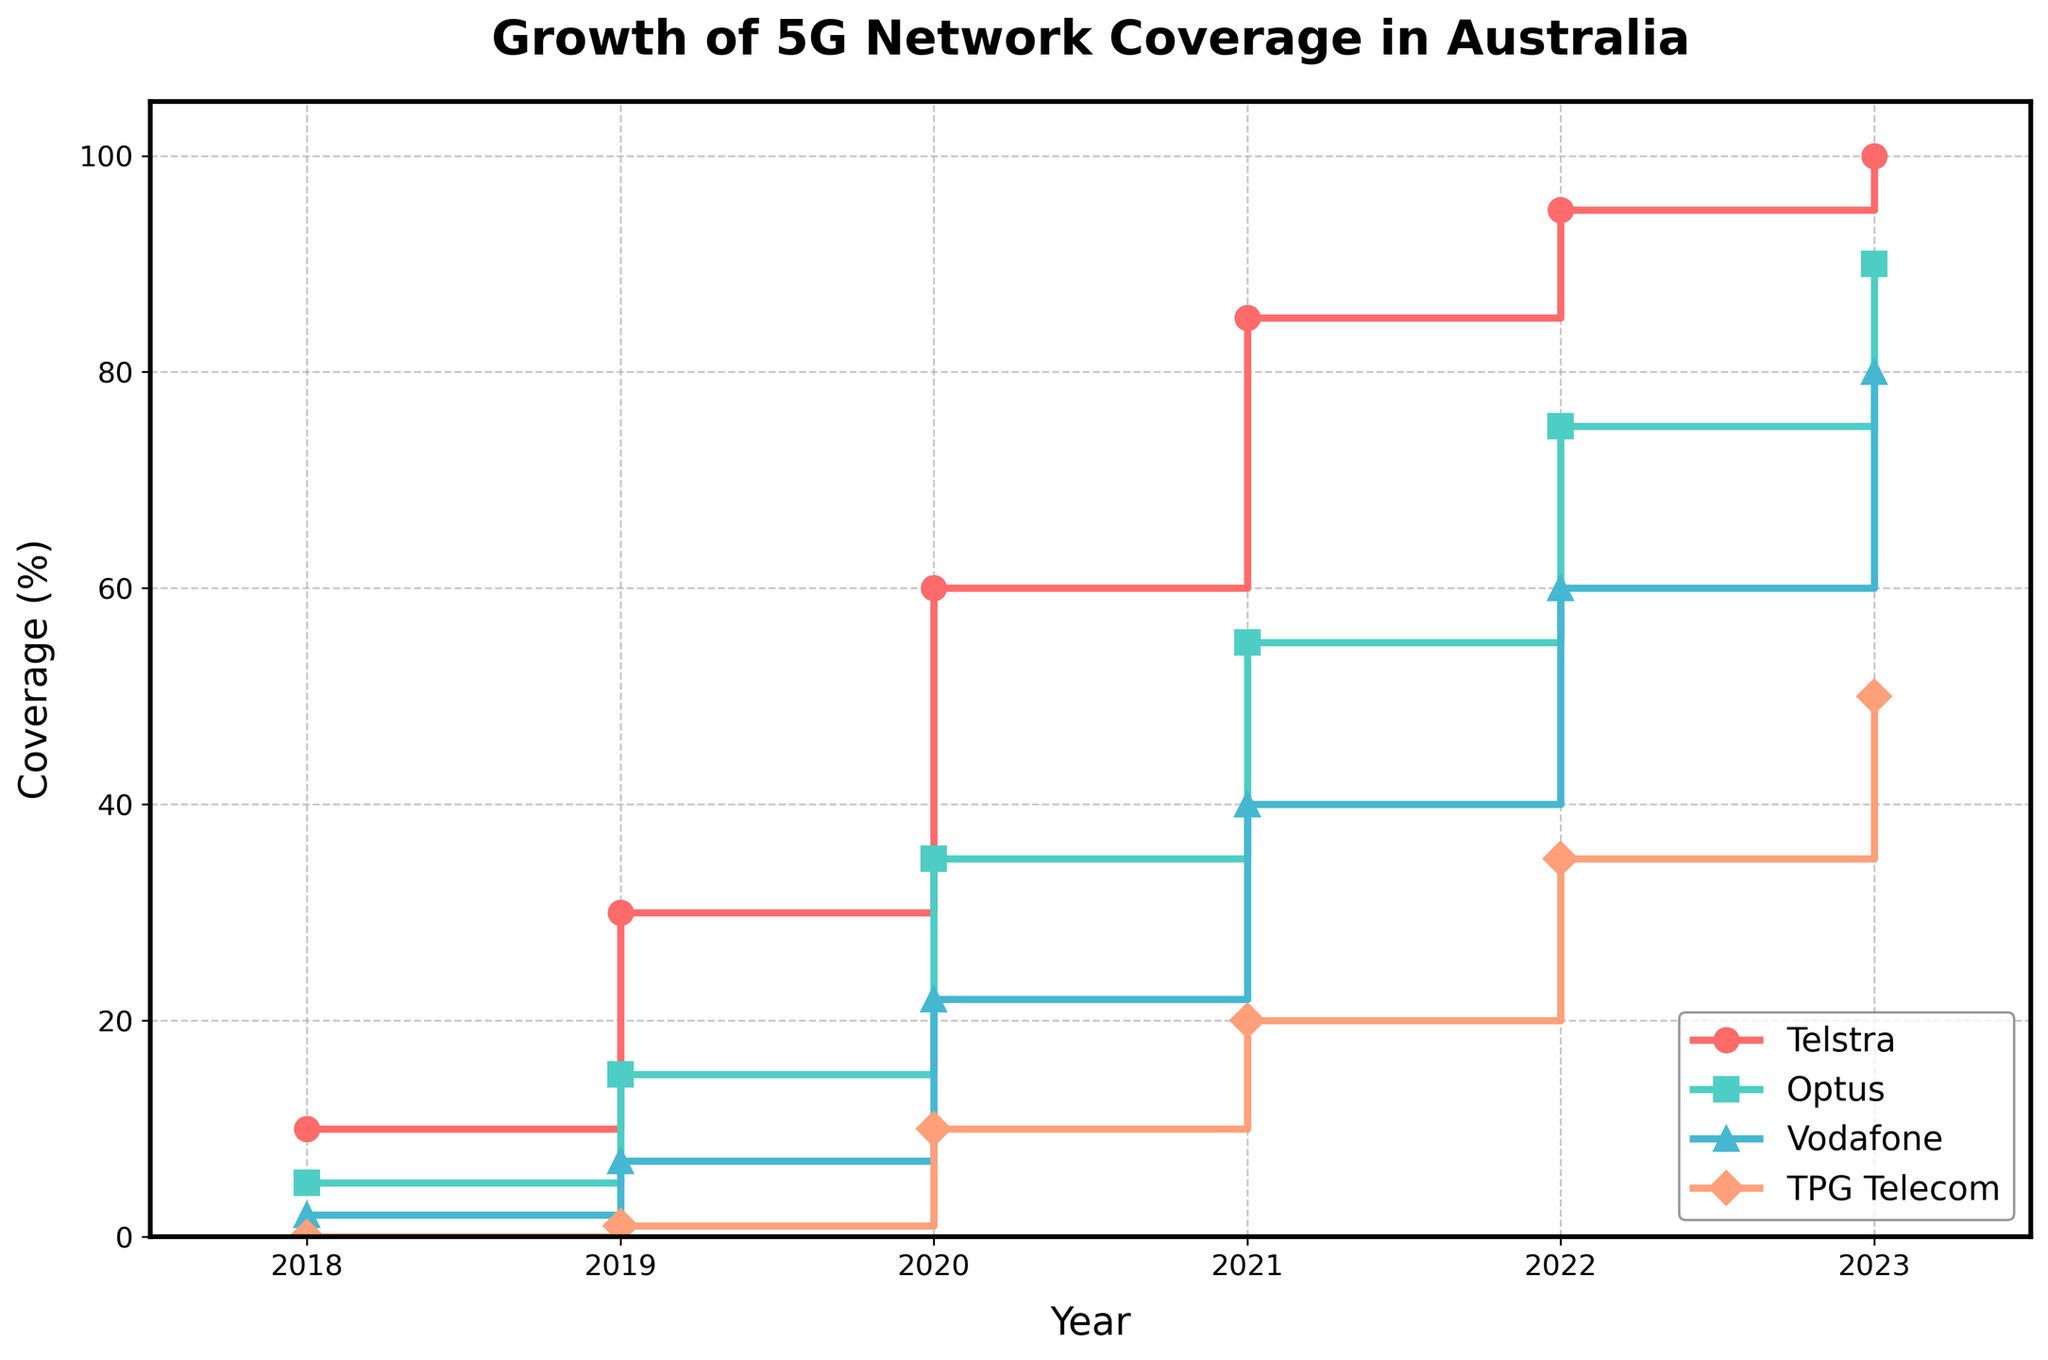What's the title of the plot? The title of the plot is displayed at the top of the figure in bold text.
Answer: Growth of 5G Network Coverage in Australia What are the companies represented in the plot? The companies are indicated by the labels in the legend located at the lower right of the plot.
Answer: Telstra, Optus, Vodafone, TPG Telecom Which company reached 100% coverage first? By looking at the steps and final values, you can see that Telstra reaches 100% coverage by 2023.
Answer: Telstra In which year did Vodafone achieve 40% coverage? Follow Vodafone's line (indicated by its color and marker type) and find where it first touches the 40% coverage on the y-axis.
Answer: 2021 How much did Optus's coverage increase from 2019 to 2020? Check the y-values for Optus in 2019 and 2020, which are 15 and 35 respectively. The difference is 35 - 15.
Answer: 20% Which company had the smallest coverage increase from 2022 to 2023? Compare the y-value differences between 2022 to 2023 for all companies. Telstra (5%), Optus (15%), Vodafone (20%), TPG Telecom (15%).
Answer: Telstra What is the average coverage of TPG Telecom between 2018 and 2023? Sum the TPG Telecom values (0 + 1 + 10 + 20 + 35 + 50), then divide by the number of years (6). Average = 116 / 6.
Answer: 19.33% Compare the coverage of Optus and Vodafone in 2020, which one is higher and by how much? Find the y-values for Optus (35) and Vodafone (22) in 2020, then calculate the difference.
Answer: Optus by 13% Which company had the fastest growth rate in coverage between 2018 and 2019? Calculate the slope (rate of change) for each company between 2018 and 2019. Telstra (20), Optus (10), Vodafone (5), TPG Telecom (1).
Answer: Telstra How many data points are plotted for each company? Each year from 2018 to 2023 is a data point, marked by years on the x-axis.
Answer: 6 